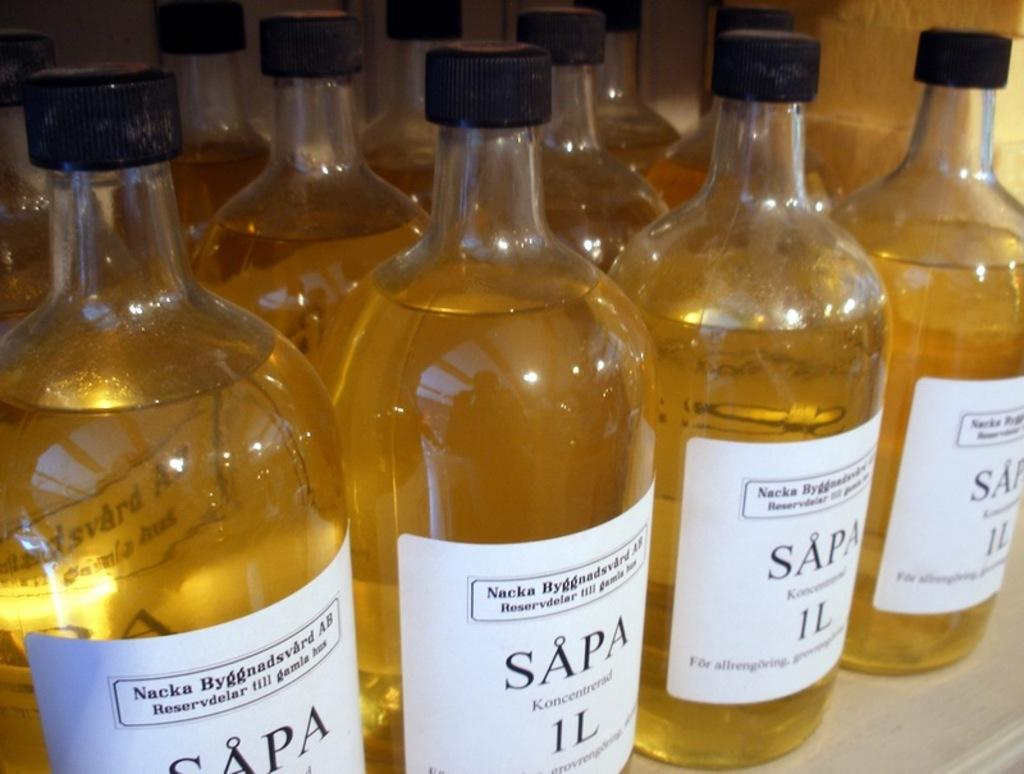What objects are present in the image? There are bottles in the image. Can you describe the bottles in the image? Unfortunately, the provided facts do not include any details about the bottles. Are there any other objects or people visible in the image? The provided facts do not mention any other objects or people in the image. What type of shoe is being advertised in the image? There is no shoe or advertisement present in the image; it only contains bottles. 